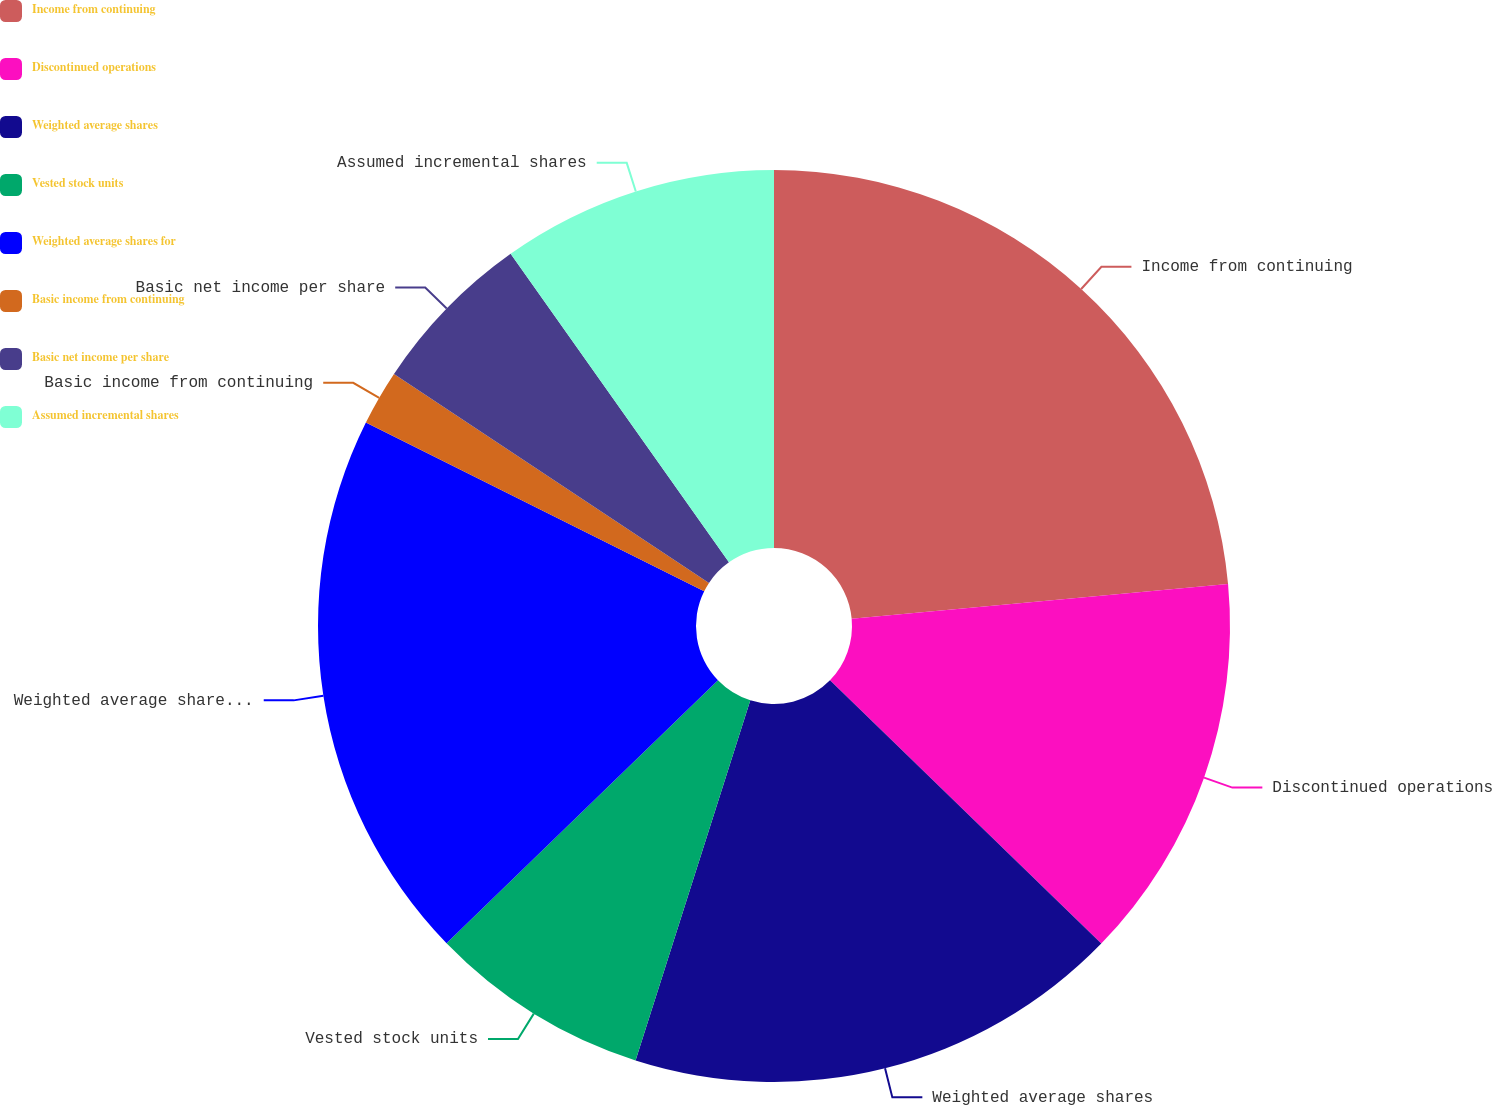<chart> <loc_0><loc_0><loc_500><loc_500><pie_chart><fcel>Income from continuing<fcel>Discontinued operations<fcel>Weighted average shares<fcel>Vested stock units<fcel>Weighted average shares for<fcel>Basic income from continuing<fcel>Basic net income per share<fcel>Assumed incremental shares<nl><fcel>23.53%<fcel>13.73%<fcel>17.65%<fcel>7.84%<fcel>19.61%<fcel>1.96%<fcel>5.88%<fcel>9.8%<nl></chart> 